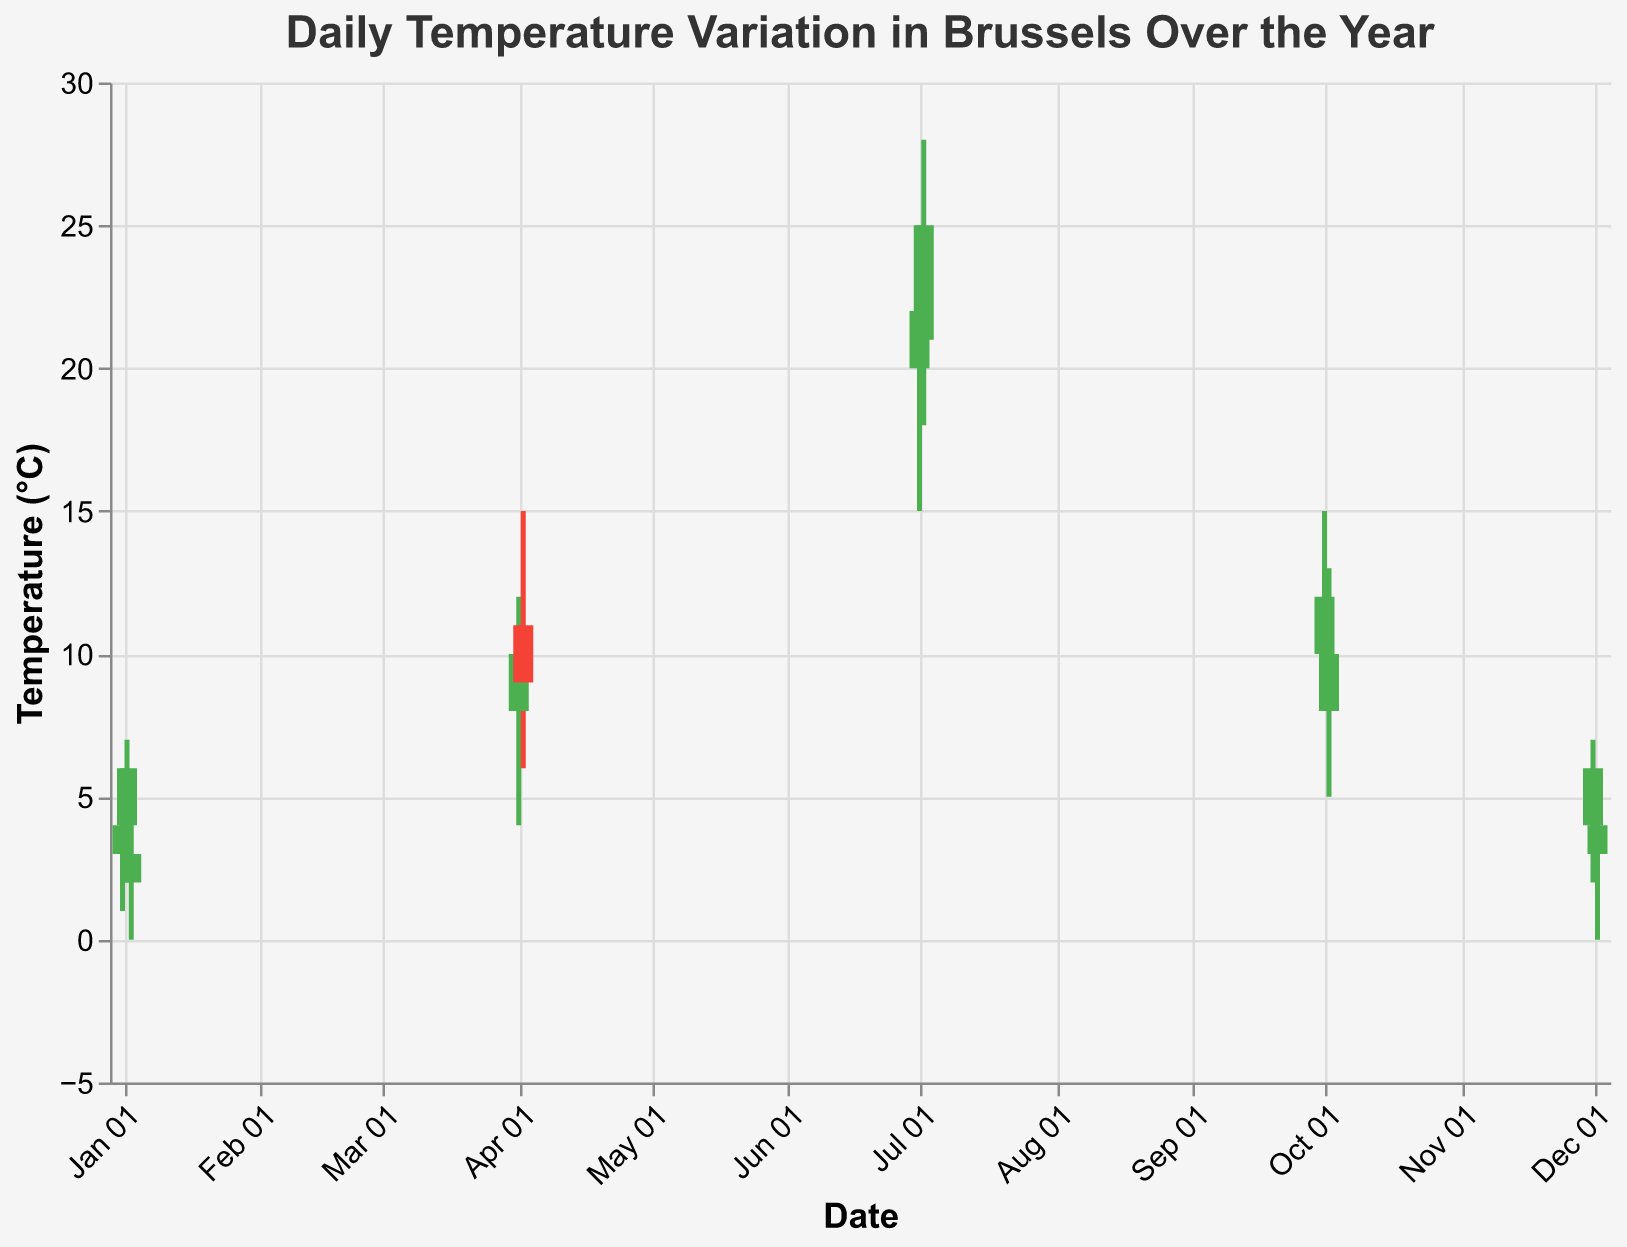Which day had the highest daily temperature? Look at the 'High' temperatures on all days, the highest temperature is 28°C on July 2, 2023.
Answer: July 2, 2023 Which day had the largest difference between the high and low temperatures? Calculate the difference between 'High' and 'Low' for each day. The largest difference is 10°C on both July 1 and July 2, 2023.
Answer: July 1, 2023 and July 2, 2023 Which day had a higher close temperature: April 1, 2023 or April 2, 2023? Compare the 'Close' temperature of April 1 (10°C) with April 2 (9°C). April 1's 'Close' temperature is higher.
Answer: April 1, 2023 How many days had increasing temperatures from 'Open' to 'Close'? Count the bars colored green, indicating 'Open' < 'Close'. There are 6 such days: January 1, January 2, April 1, July 1, July 2, and December 1.
Answer: 6 days What was the low temperature on January 3, 2023? Check the 'Low' temperature value for January 3, which is 0°C.
Answer: 0°C What was the temperature range on April 1, 2023? Subtract 'Low' (4°C) from 'High' (12°C) to get the temperature range. The range is 12 - 4 = 8°C.
Answer: 8°C Which month had the most temperature variation across different days? Compare the differences between 'High' and 'Low' in each month. July shows the most variation with temperatures ranging from 15°C to 28°C.
Answer: July How did the temperature behave on December 2, 2023: did it increase or decrease? The 'Open' temperature is 3°C and the 'Close' temperature is 4°C. It increased.
Answer: Increased Which day in October had the highest high temperature? Compare the 'High' temperatures on October 1 and October 2: 15°C vs. 13°C. October 1 had the highest 'High'.
Answer: October 1, 2023 On which day did the 'Close' temperature end lower than the 'Open' temperature? Check for red bars where 'Open' > 'Close'. These days are April 2 and October 2.
Answer: April 2, 2023 and October 2, 2023 